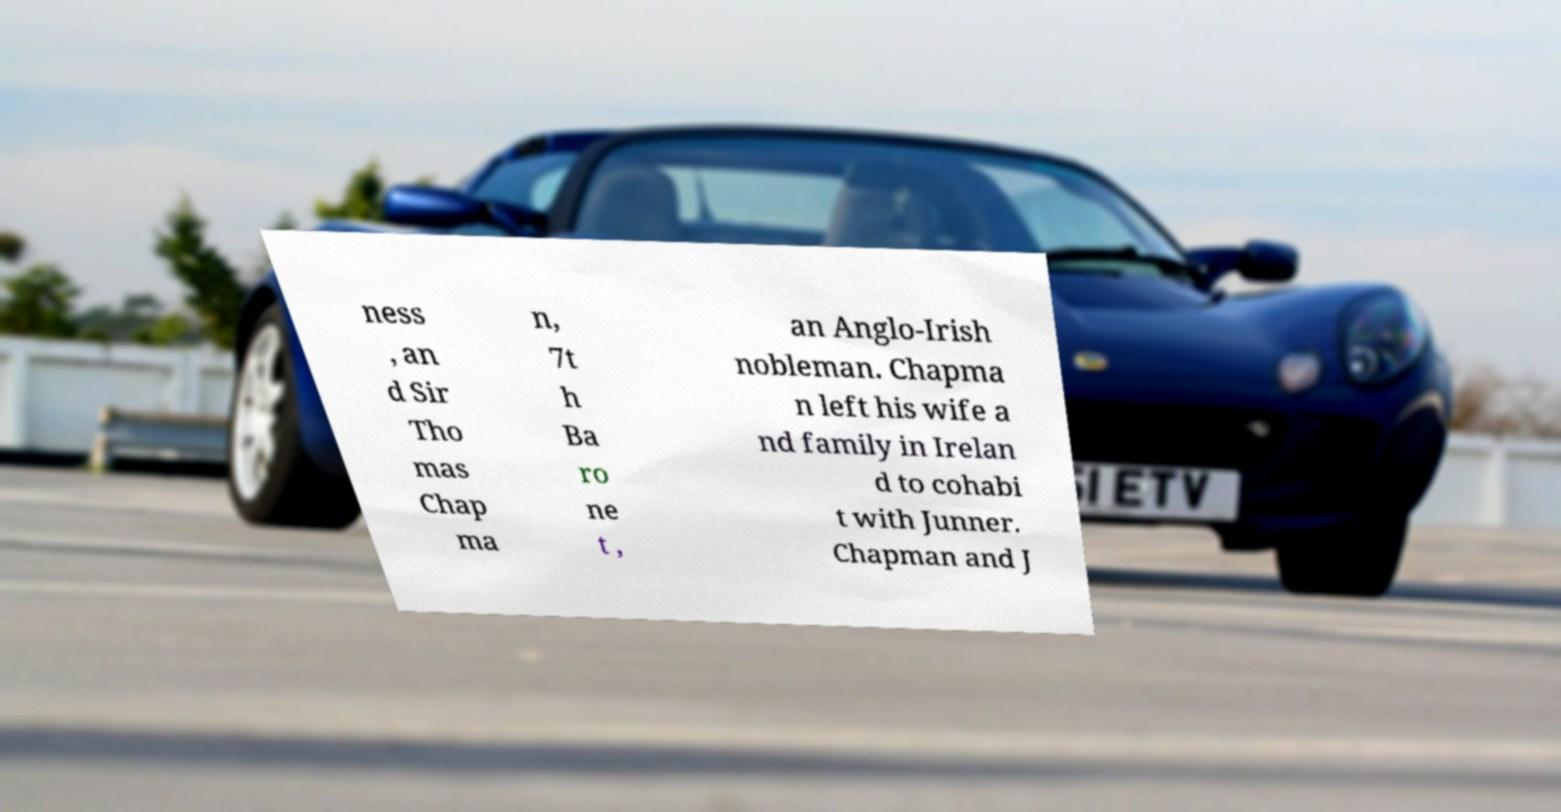Could you extract and type out the text from this image? ness , an d Sir Tho mas Chap ma n, 7t h Ba ro ne t , an Anglo-Irish nobleman. Chapma n left his wife a nd family in Irelan d to cohabi t with Junner. Chapman and J 